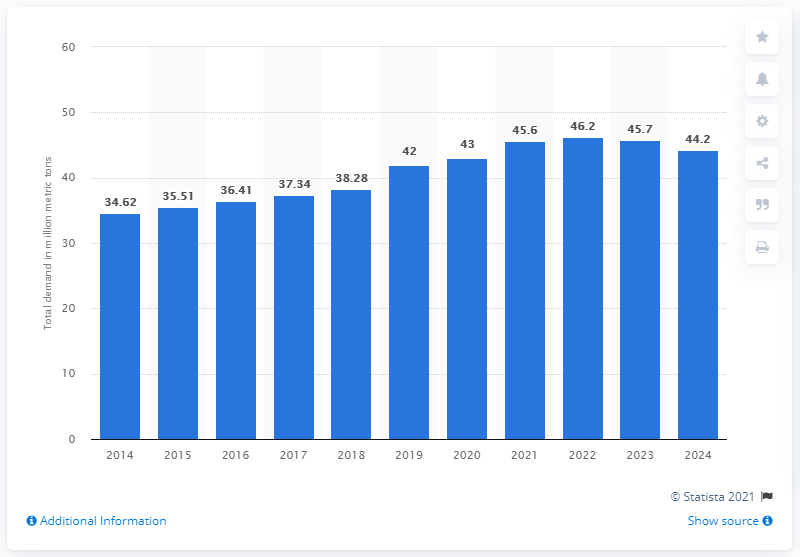List a handful of essential elements in this visual. The global demand for potash fertilizers is expected to reach 44.2 million metric tons in 2024. 